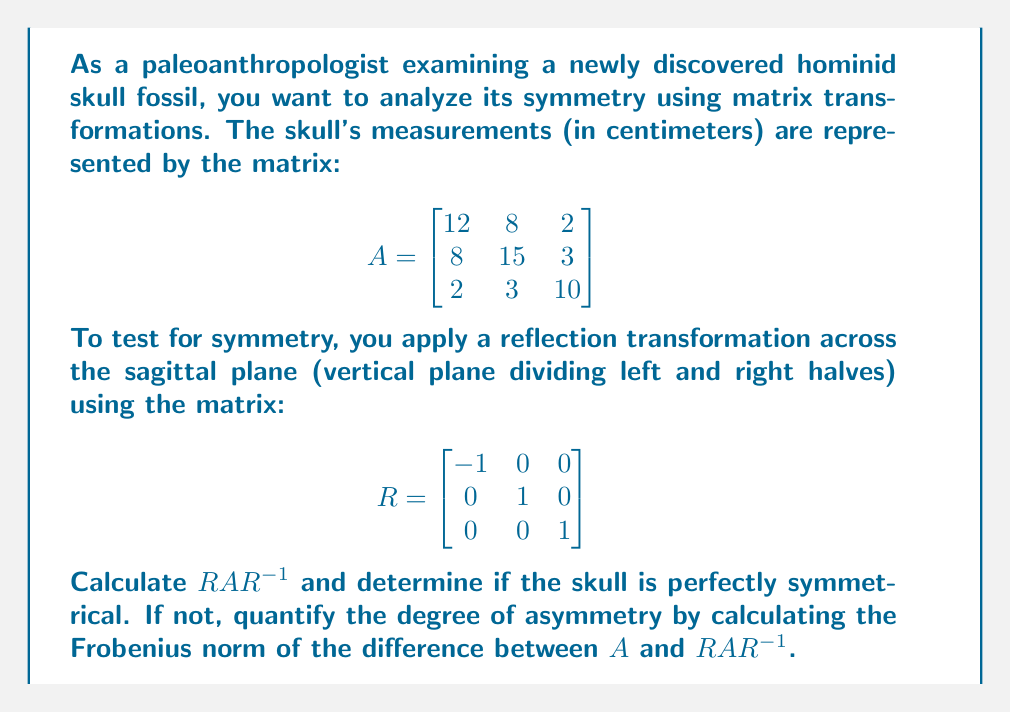Solve this math problem. To analyze the symmetry of the skull using matrix transformations, we'll follow these steps:

1) First, we need to calculate $RAR^{-1}$. 

   Note that $R^{-1} = R$ for this reflection matrix.

   $RAR^{-1} = RAR$

2) Let's calculate $RA$ first:

   $$RA = \begin{bmatrix}
   -1 & 0 & 0 \\
   0 & 1 & 0 \\
   0 & 0 & 1
   \end{bmatrix}
   \begin{bmatrix}
   12 & 8 & 2 \\
   8 & 15 & 3 \\
   2 & 3 & 10
   \end{bmatrix} = 
   \begin{bmatrix}
   -12 & -8 & -2 \\
   8 & 15 & 3 \\
   2 & 3 & 10
   \end{bmatrix}$$

3) Now let's multiply this result by $R$ again:

   $$RAR = \begin{bmatrix}
   -1 & 0 & 0 \\
   0 & 1 & 0 \\
   0 & 0 & 1
   \end{bmatrix}
   \begin{bmatrix}
   -12 & -8 & -2 \\
   8 & 15 & 3 \\
   2 & 3 & 10
   \end{bmatrix} = 
   \begin{bmatrix}
   12 & 8 & 2 \\
   8 & 15 & 3 \\
   2 & 3 & 10
   \end{bmatrix}$$

4) We can see that $RAR^{-1} = A$, which means the skull is perfectly symmetrical across the sagittal plane.

5) Since the skull is perfectly symmetrical, the difference between $A$ and $RAR^{-1}$ is zero, so the Frobenius norm of this difference is also zero.

The Frobenius norm is defined as:

$$\|A\|_F = \sqrt{\sum_{i=1}^m \sum_{j=1}^n |a_{ij}|^2}$$

where $a_{ij}$ are the elements of the matrix.

In this case, $\|A - RAR^{-1}\|_F = \|0\|_F = 0$
Answer: The skull is perfectly symmetrical across the sagittal plane because $RAR^{-1} = A$. The degree of asymmetry, calculated as the Frobenius norm of $A - RAR^{-1}$, is 0. 